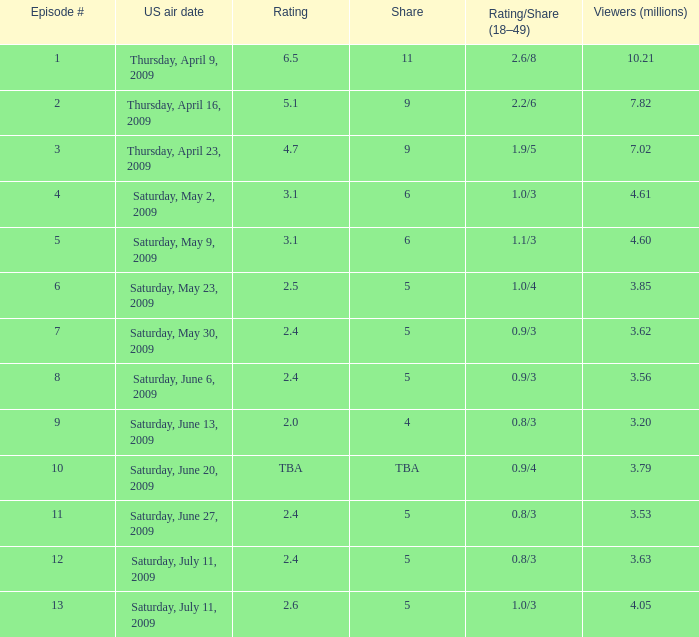With a 4% share in episode 11, what was the average count of million viewers in the episodes preceding it? 3.2. 